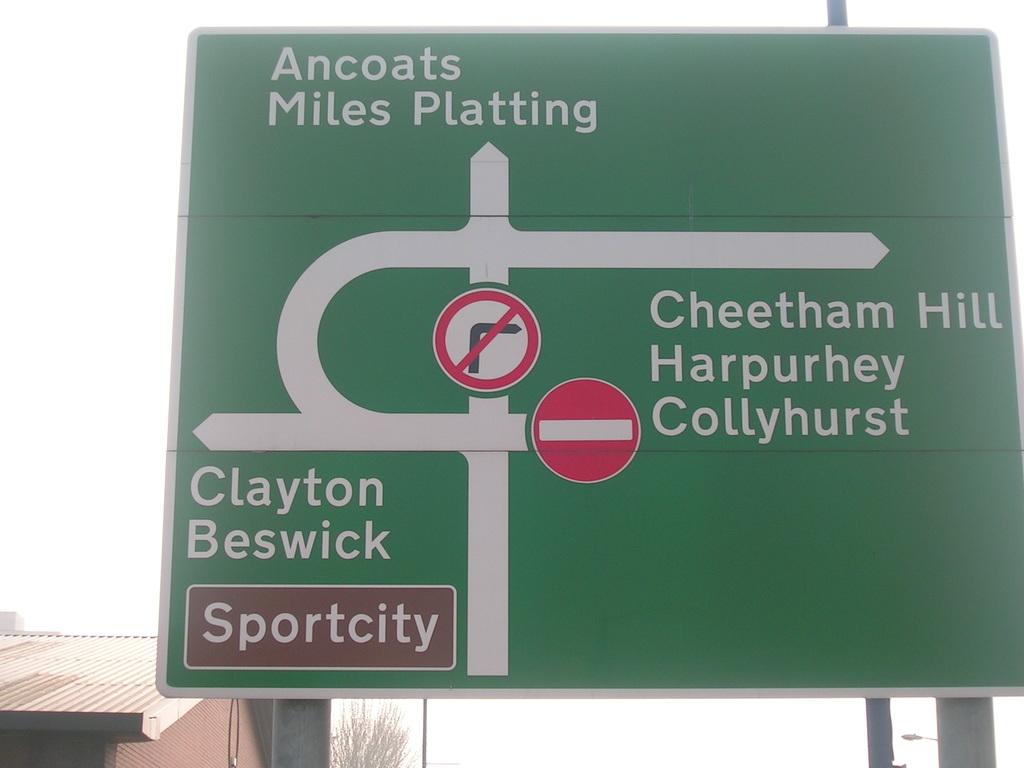Provide a one-sentence caption for the provided image. A large green sign shows directions to Sportcity. 